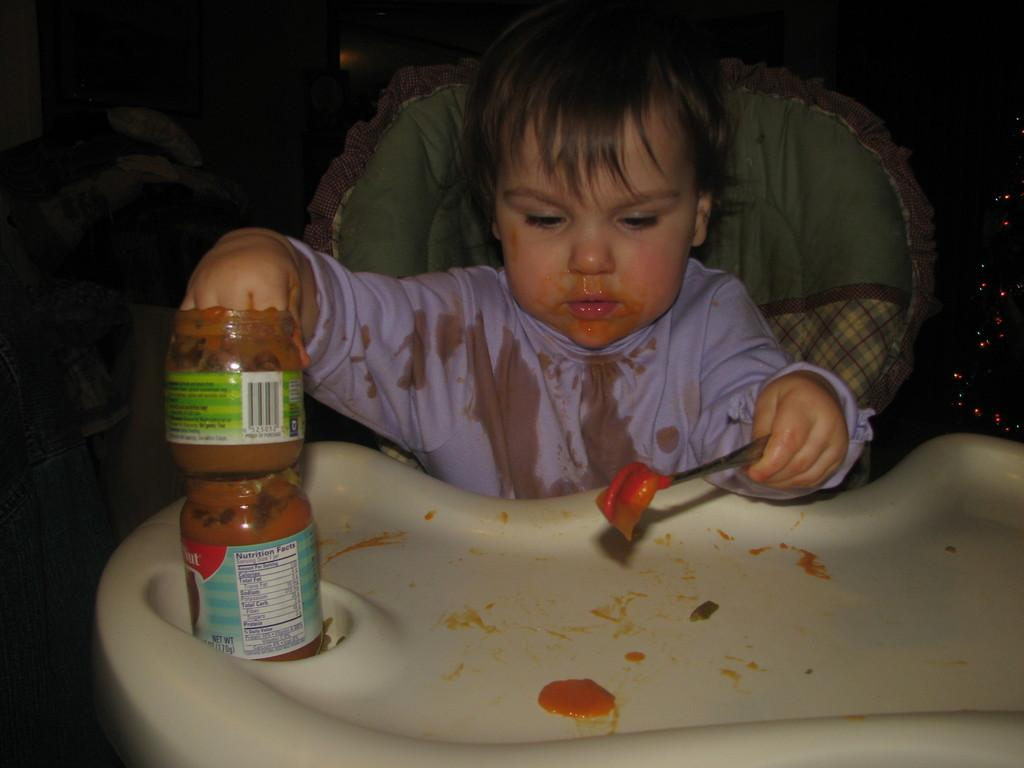What is the main subject of the image? The main subject of the image is a kid. What is the kid doing in the image? The kid is sitting on a chair and holding a jar with jam in it. What else is the kid holding in the image? The kid is also holding a spoon in the other hand. What type of cake is the kid eating in the image? A: There is no cake present in the image; the kid is holding a jar of jam and a spoon. 